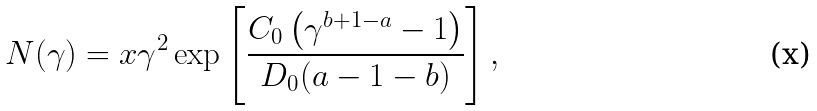<formula> <loc_0><loc_0><loc_500><loc_500>N ( \gamma ) = x \gamma ^ { 2 } \exp \left [ \frac { C _ { 0 } \left ( \gamma ^ { b + 1 - a } - 1 \right ) } { D _ { 0 } ( a - 1 - b ) } \right ] ,</formula> 